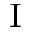Convert formula to latex. <formula><loc_0><loc_0><loc_500><loc_500>^ { I }</formula> 